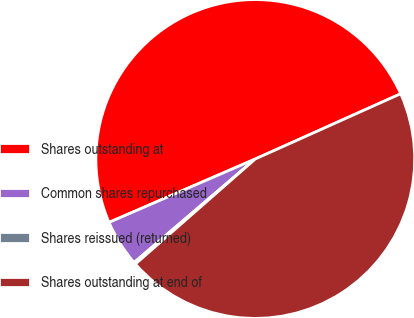Convert chart. <chart><loc_0><loc_0><loc_500><loc_500><pie_chart><fcel>Shares outstanding at<fcel>Common shares repurchased<fcel>Shares reissued (returned)<fcel>Shares outstanding at end of<nl><fcel>49.8%<fcel>4.74%<fcel>0.2%<fcel>45.26%<nl></chart> 